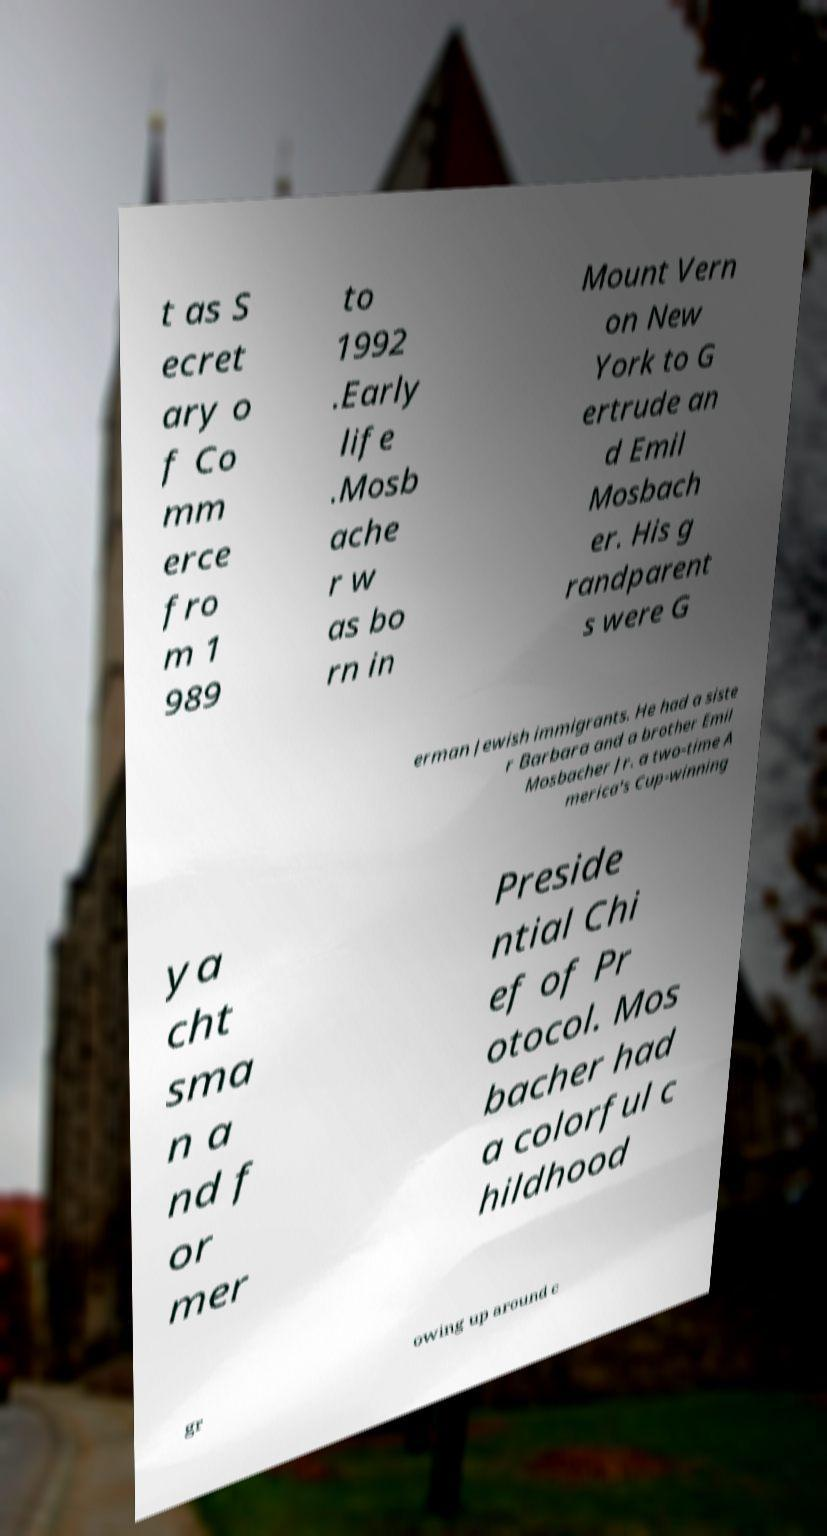There's text embedded in this image that I need extracted. Can you transcribe it verbatim? t as S ecret ary o f Co mm erce fro m 1 989 to 1992 .Early life .Mosb ache r w as bo rn in Mount Vern on New York to G ertrude an d Emil Mosbach er. His g randparent s were G erman Jewish immigrants. He had a siste r Barbara and a brother Emil Mosbacher Jr. a two-time A merica's Cup-winning ya cht sma n a nd f or mer Preside ntial Chi ef of Pr otocol. Mos bacher had a colorful c hildhood gr owing up around c 